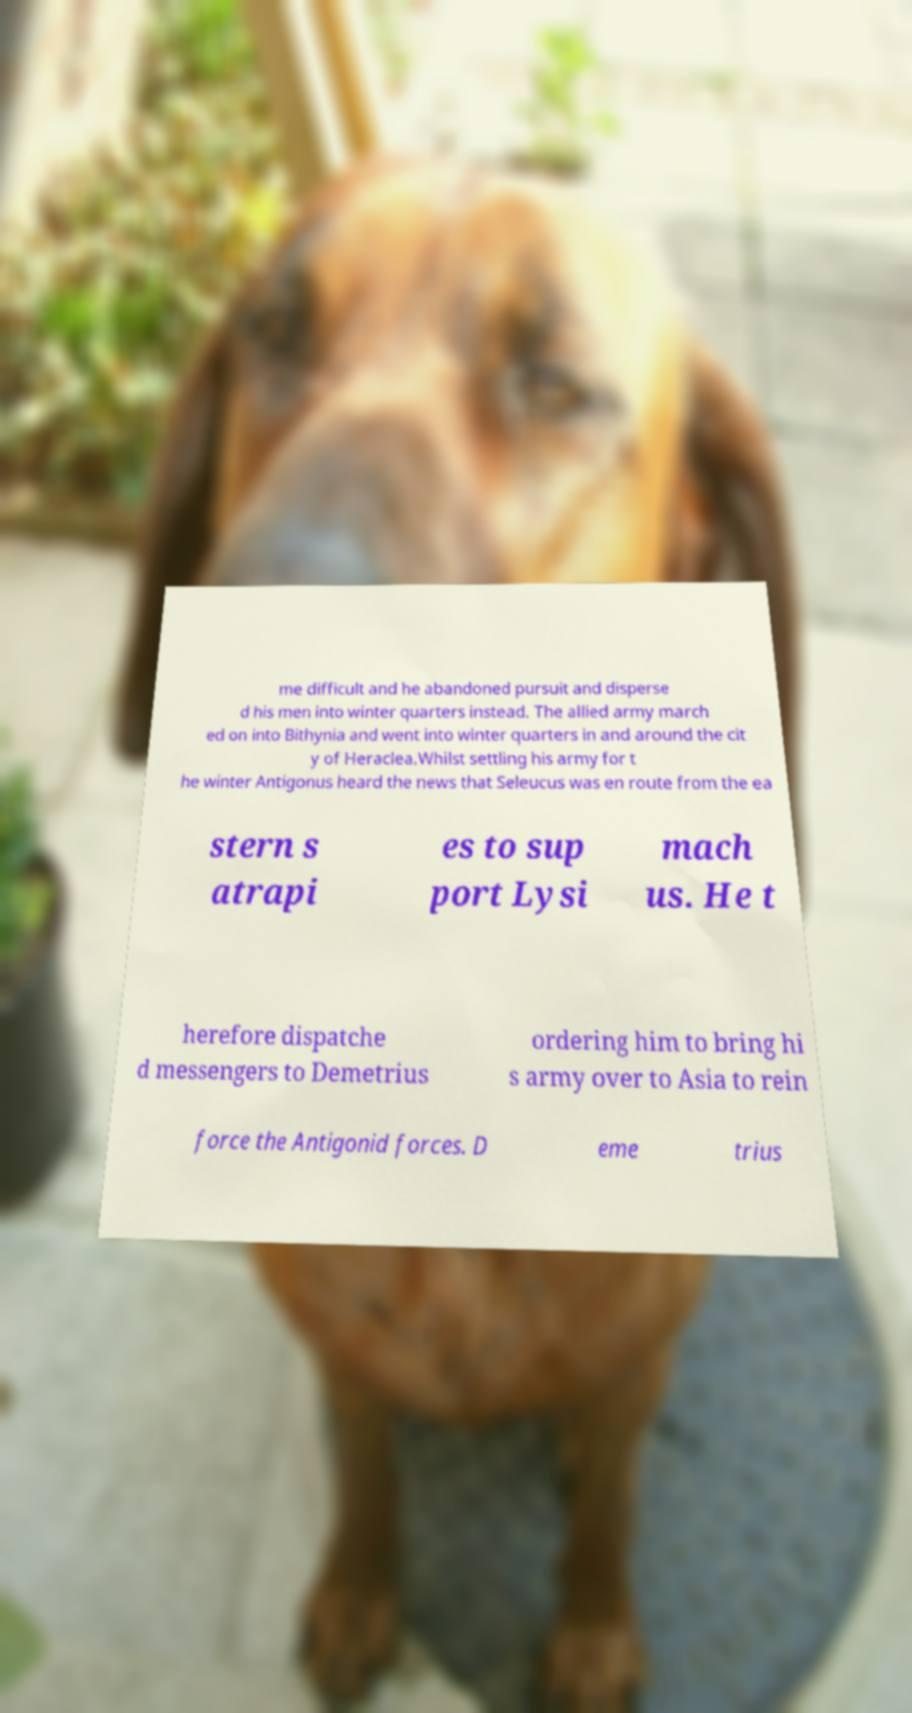Could you assist in decoding the text presented in this image and type it out clearly? me difficult and he abandoned pursuit and disperse d his men into winter quarters instead. The allied army march ed on into Bithynia and went into winter quarters in and around the cit y of Heraclea.Whilst settling his army for t he winter Antigonus heard the news that Seleucus was en route from the ea stern s atrapi es to sup port Lysi mach us. He t herefore dispatche d messengers to Demetrius ordering him to bring hi s army over to Asia to rein force the Antigonid forces. D eme trius 